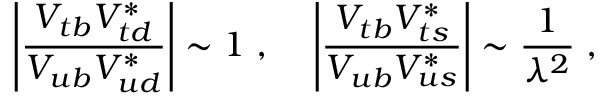Convert formula to latex. <formula><loc_0><loc_0><loc_500><loc_500>\left | \frac { V _ { t b } V _ { t d } ^ { * } } { V _ { u b } V _ { u d } ^ { * } } \right | \sim 1 \, , \, \left | \frac { V _ { t b } V _ { t s } ^ { * } } { V _ { u b } V _ { u s } ^ { * } } \right | \sim \frac { 1 } { \lambda ^ { 2 } } \, ,</formula> 